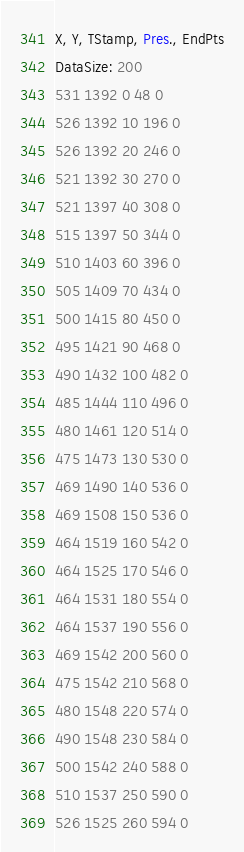<code> <loc_0><loc_0><loc_500><loc_500><_SML_>X, Y, TStamp, Pres., EndPts
DataSize: 200
531 1392 0 48 0
526 1392 10 196 0
526 1392 20 246 0
521 1392 30 270 0
521 1397 40 308 0
515 1397 50 344 0
510 1403 60 396 0
505 1409 70 434 0
500 1415 80 450 0
495 1421 90 468 0
490 1432 100 482 0
485 1444 110 496 0
480 1461 120 514 0
475 1473 130 530 0
469 1490 140 536 0
469 1508 150 536 0
464 1519 160 542 0
464 1525 170 546 0
464 1531 180 554 0
464 1537 190 556 0
469 1542 200 560 0
475 1542 210 568 0
480 1548 220 574 0
490 1548 230 584 0
500 1542 240 588 0
510 1537 250 590 0
526 1525 260 594 0</code> 